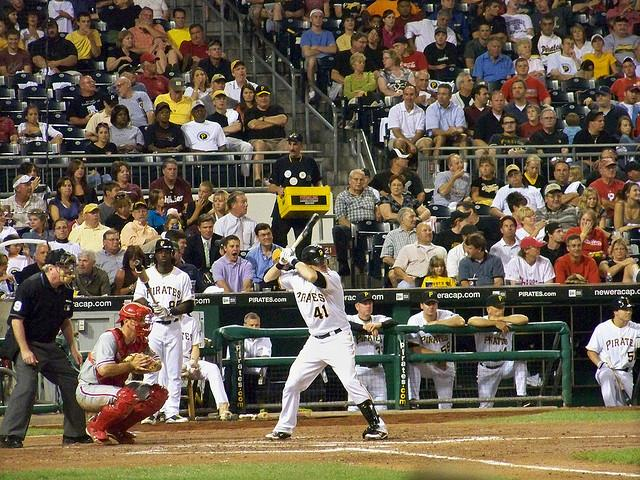What number is the batter wearing?

Choices:
A) 41
B) 99
C) 77
D) 83 41 